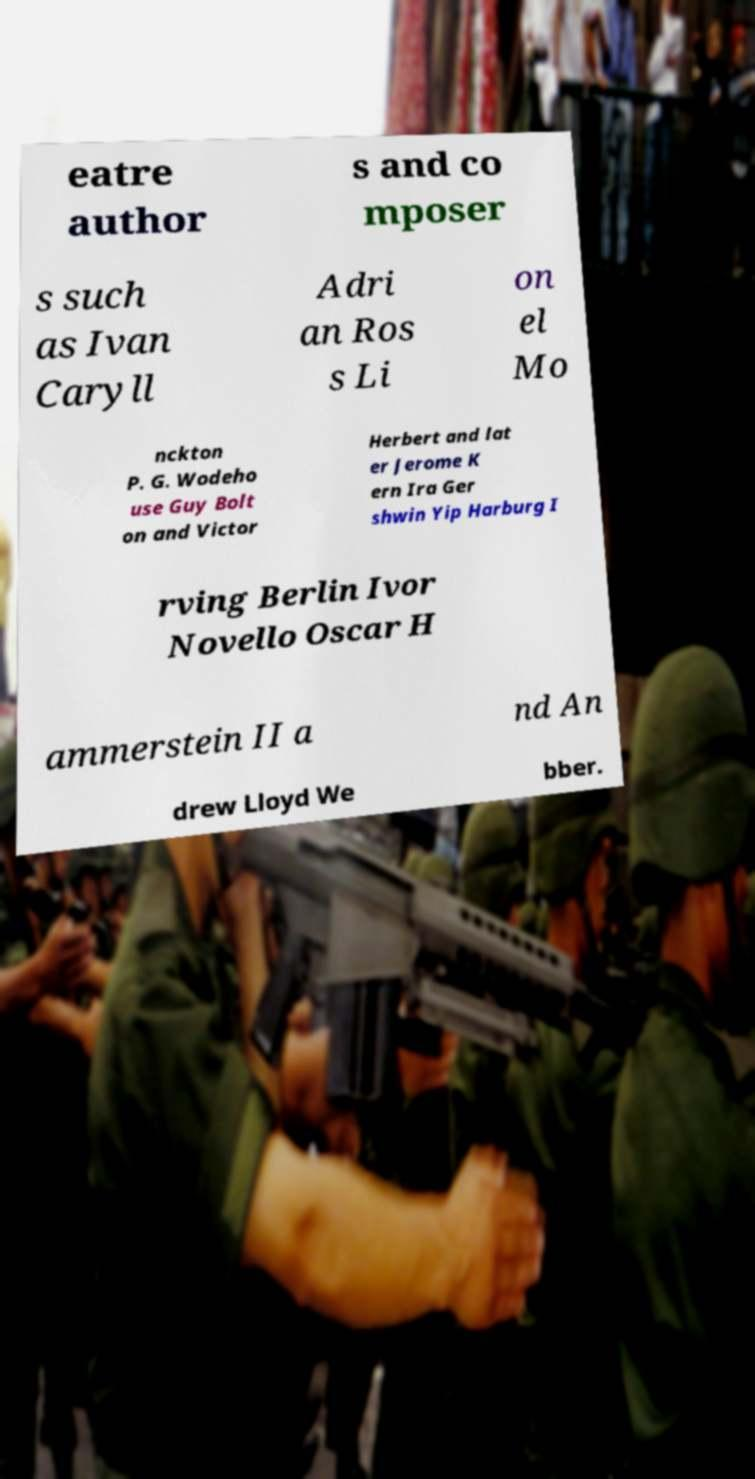Please identify and transcribe the text found in this image. eatre author s and co mposer s such as Ivan Caryll Adri an Ros s Li on el Mo nckton P. G. Wodeho use Guy Bolt on and Victor Herbert and lat er Jerome K ern Ira Ger shwin Yip Harburg I rving Berlin Ivor Novello Oscar H ammerstein II a nd An drew Lloyd We bber. 